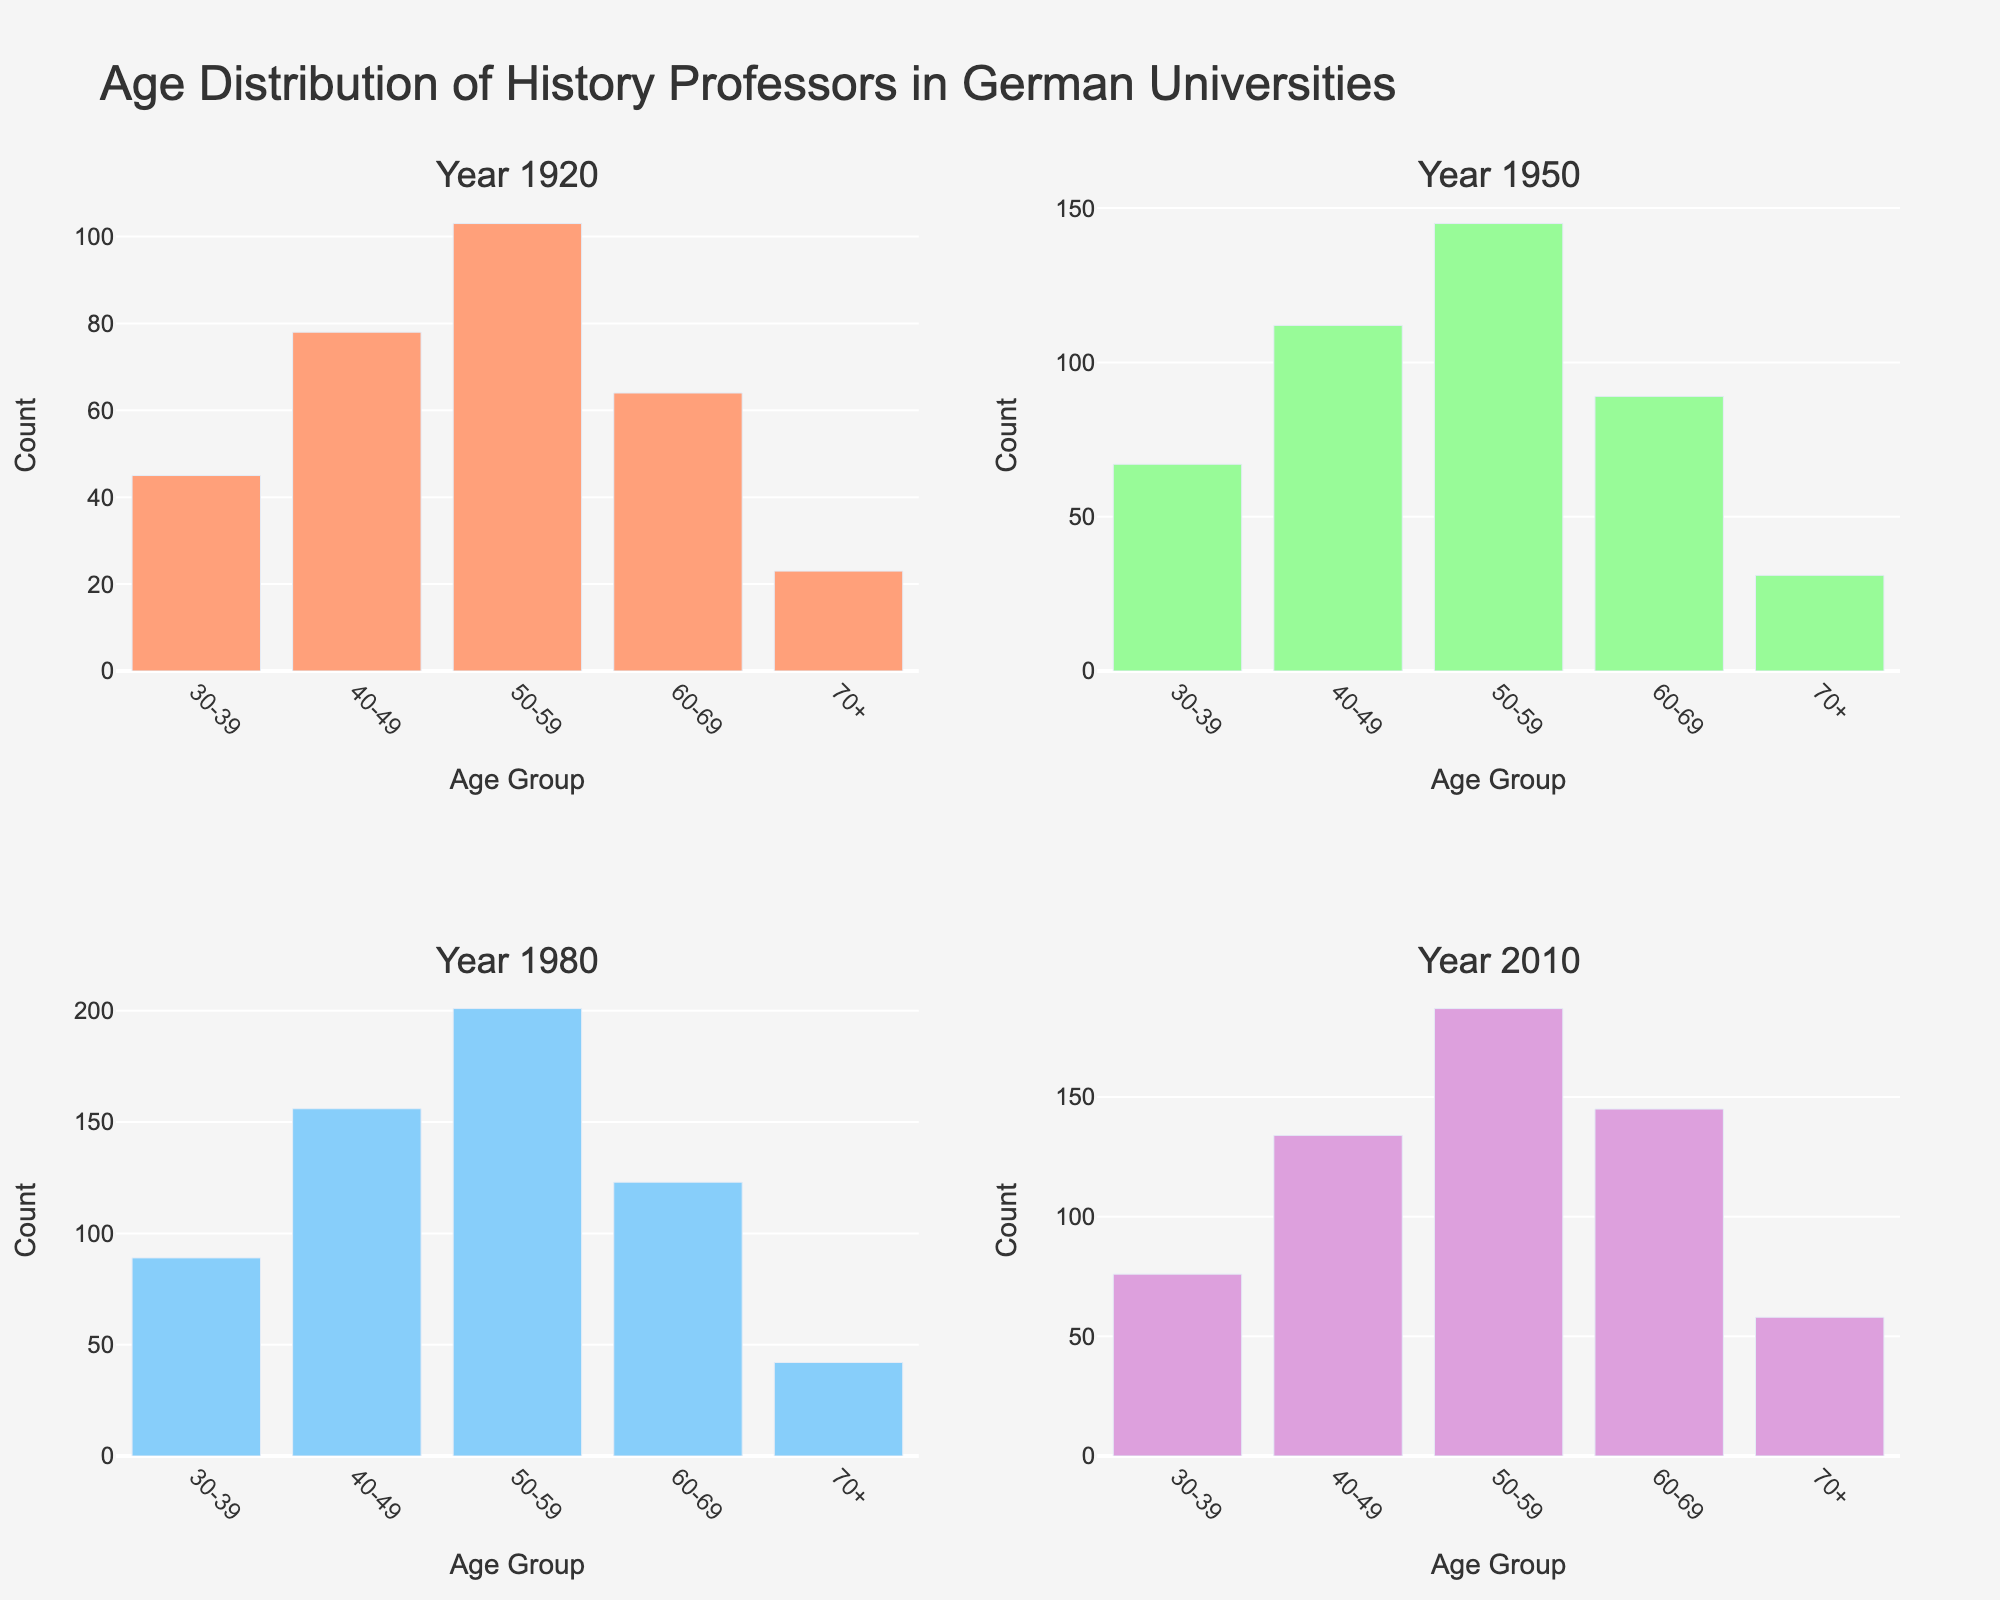How many age groups are represented in each subplot? Each of the four subplots represents five age groups. These are visible under the x-axis labeled as 'Age Group' in each year-specific subplot.
Answer: 5 Which age group had the highest count in 1920? In the subplot for the year 1920, the bar representing the 50-59 age group is the tallest.
Answer: 50-59 What is the total count of history professors in 1950? Sum the heights of all the bars in the 1950 subplot: 67 (30-39) + 112 (40-49) + 145 (50-59) + 89 (60-69) + 31 (70+) = 444.
Answer: 444 Which year had the highest number of professors aged 70 and above? Compare the height of the 70+ bar in all subplots: 23 (1920), 31 (1950), 42 (1980), 58 (2010). The highest count is in 2010.
Answer: 2010 What is the increase in the number of 40-49-year-olds from 1920 to 1950? Subtract the 40-49 count in 1920 from the 40-49 count in 1950: 112 - 78 = 34.
Answer: 34 Did the number of professors aged 60-69 increase or decrease from 1980 to 2010? Compare the count of the 60-69 age group in 1980 to that in 2010: 123 in 1980 and 145 in 2010. The count increased.
Answer: Increase What trend do you observe for the number of history professors aged 50-59 across the four years? The counts for the 50-59 age group over the years are: 103 (1920), 145 (1950), 201 (1980), 187 (2010). There is a general upward trend from 1920 to 1980, followed by a slight decrease in 2010.
Answer: Up, then down 